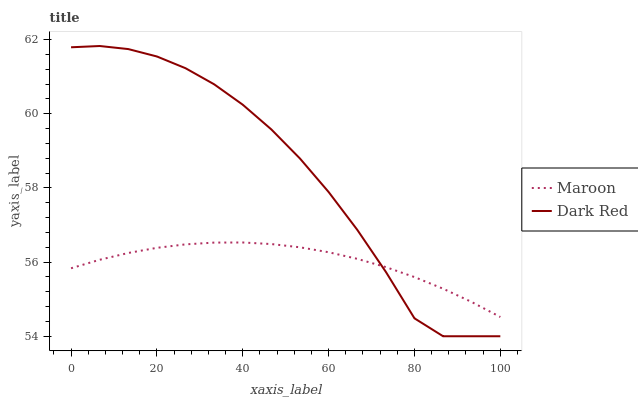Does Maroon have the minimum area under the curve?
Answer yes or no. Yes. Does Dark Red have the maximum area under the curve?
Answer yes or no. Yes. Does Maroon have the maximum area under the curve?
Answer yes or no. No. Is Maroon the smoothest?
Answer yes or no. Yes. Is Dark Red the roughest?
Answer yes or no. Yes. Is Maroon the roughest?
Answer yes or no. No. Does Dark Red have the lowest value?
Answer yes or no. Yes. Does Maroon have the lowest value?
Answer yes or no. No. Does Dark Red have the highest value?
Answer yes or no. Yes. Does Maroon have the highest value?
Answer yes or no. No. Does Maroon intersect Dark Red?
Answer yes or no. Yes. Is Maroon less than Dark Red?
Answer yes or no. No. Is Maroon greater than Dark Red?
Answer yes or no. No. 